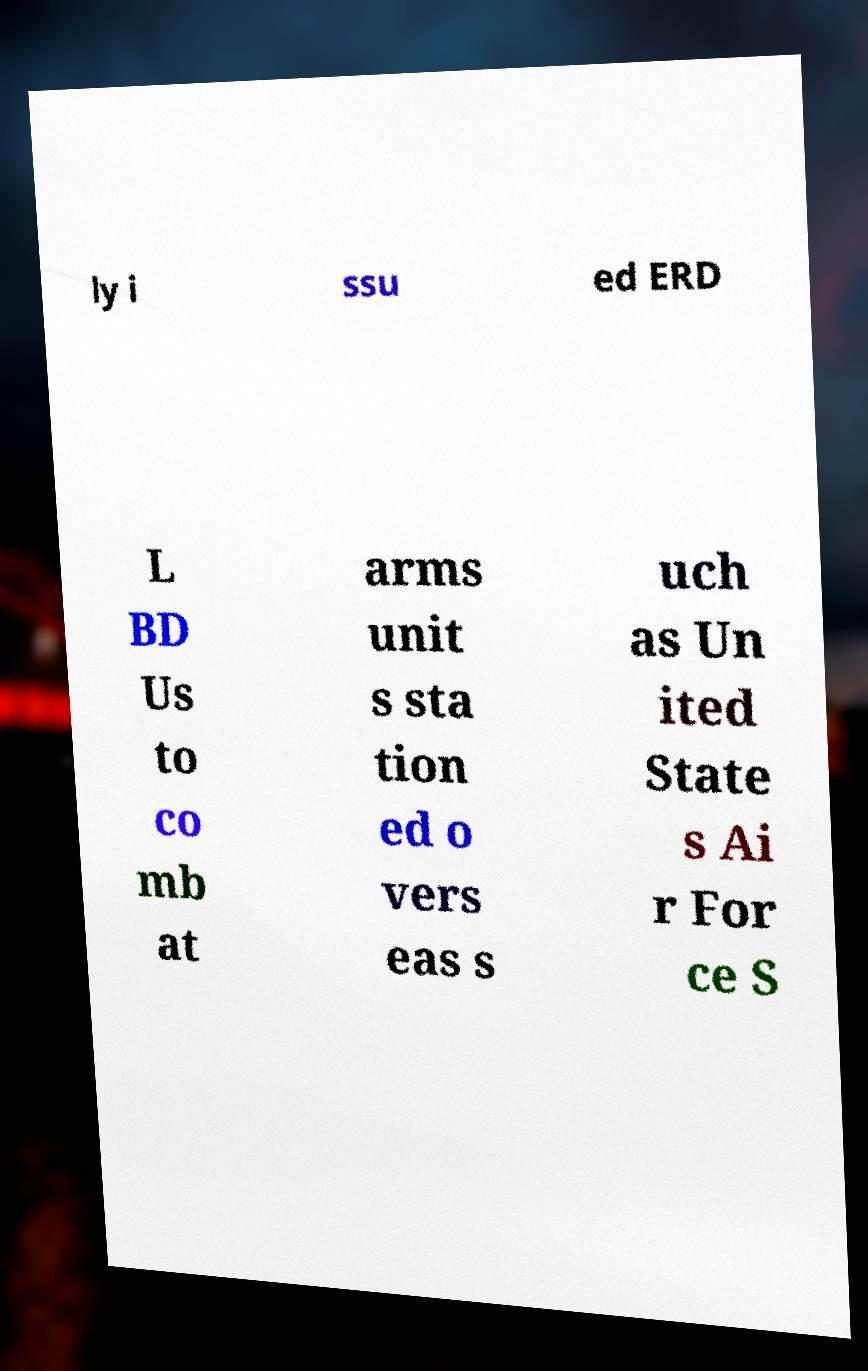Please read and relay the text visible in this image. What does it say? ly i ssu ed ERD L BD Us to co mb at arms unit s sta tion ed o vers eas s uch as Un ited State s Ai r For ce S 